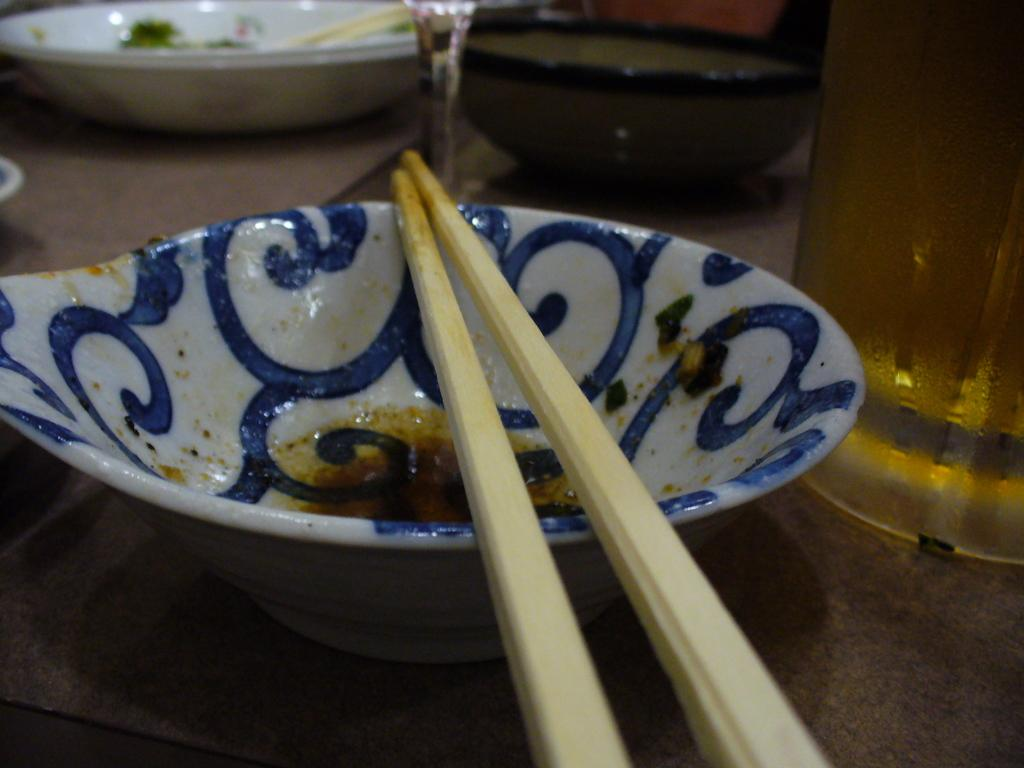What objects are on the table in the image? There are bowls on a table in the image. What utensils are present in the image? There are chopsticks in the image. What type of ear is visible in the image? There is no ear present in the image; it features bowls and chopsticks on a table. What journey is being depicted in the image? There is no journey depicted in the image; it shows bowls and chopsticks on a table. 